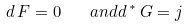Convert formula to latex. <formula><loc_0><loc_0><loc_500><loc_500>d \, F = 0 \quad a n d d \, ^ { * } \, G = j</formula> 